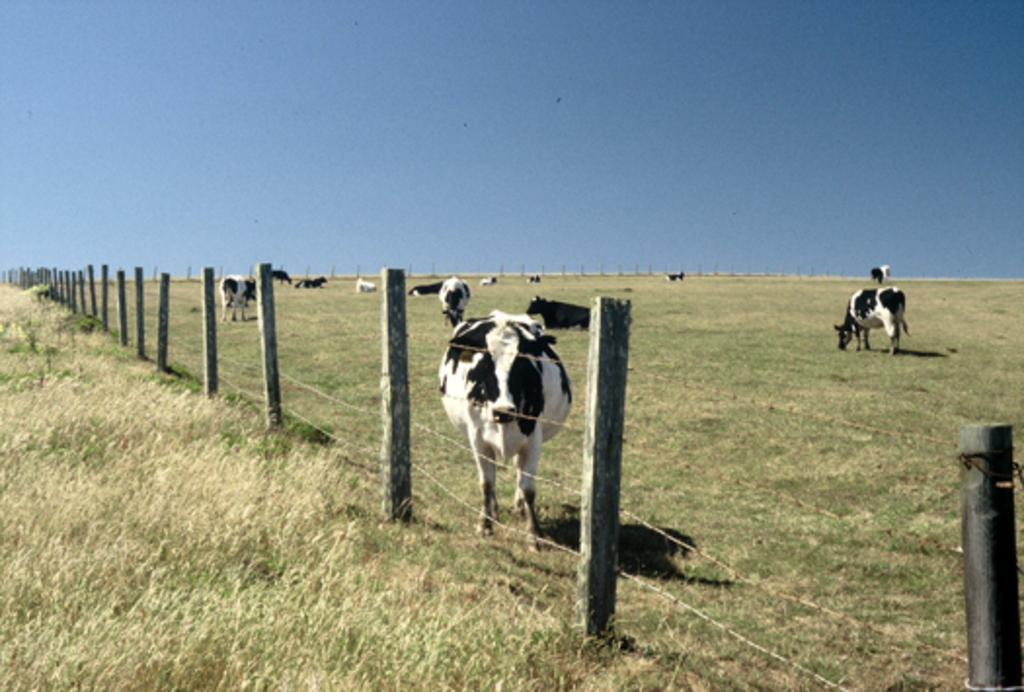Please provide a concise description of this image. In this image there are animals and we can see a fence. At the bottom there is grass. In the background there is sky. 